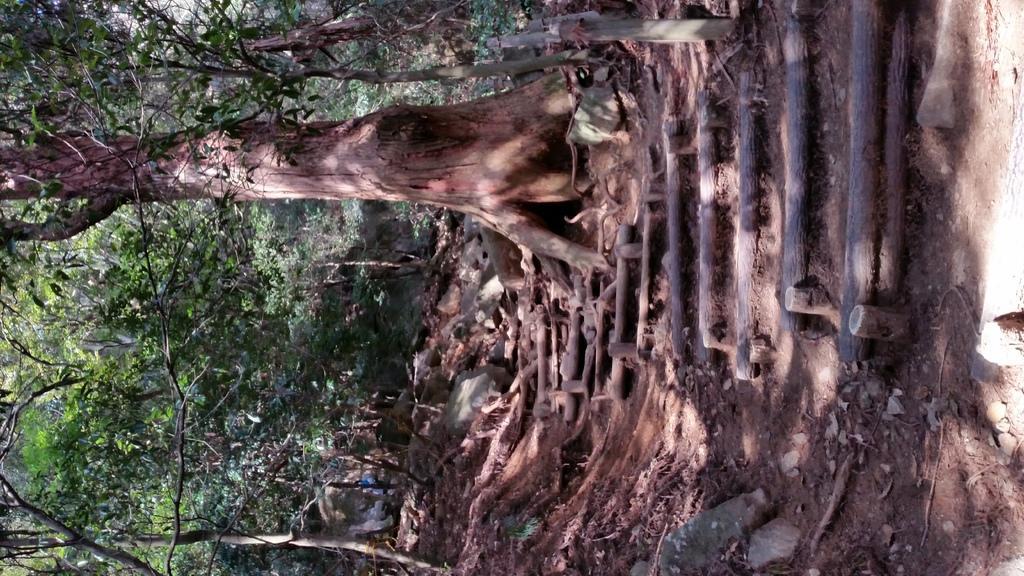Please provide a concise description of this image. This is a rotated image. In this image there are trees and few wooden sticks are arranged on the surface. 